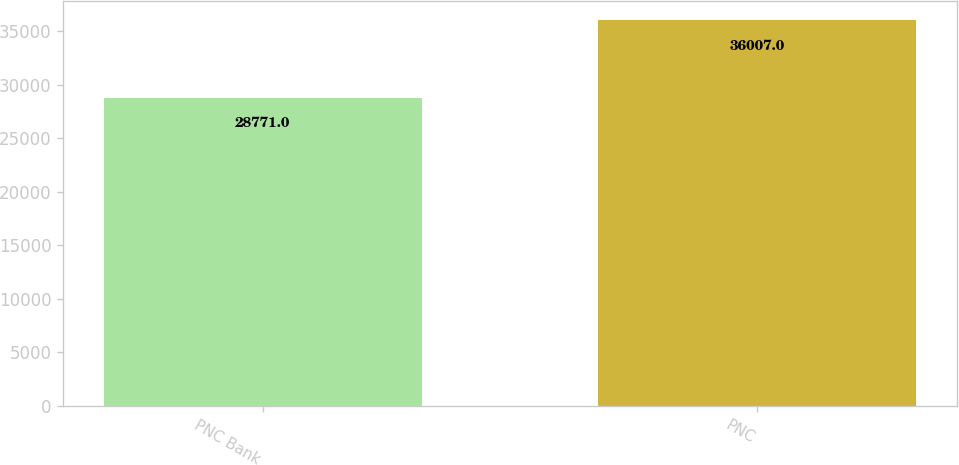<chart> <loc_0><loc_0><loc_500><loc_500><bar_chart><fcel>PNC Bank<fcel>PNC<nl><fcel>28771<fcel>36007<nl></chart> 